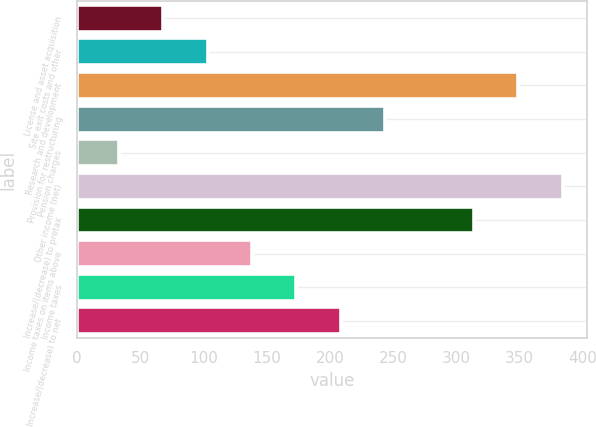<chart> <loc_0><loc_0><loc_500><loc_500><bar_chart><fcel>License and asset acquisition<fcel>Site exit costs and other<fcel>Research and development<fcel>Provision for restructuring<fcel>Pension charges<fcel>Other income (net)<fcel>Increase/(decrease) to pretax<fcel>Income taxes on items above<fcel>Income taxes<fcel>Increase/(decrease) to net<nl><fcel>68.1<fcel>103.2<fcel>348.9<fcel>243.6<fcel>33<fcel>384<fcel>313.8<fcel>138.3<fcel>173.4<fcel>208.5<nl></chart> 